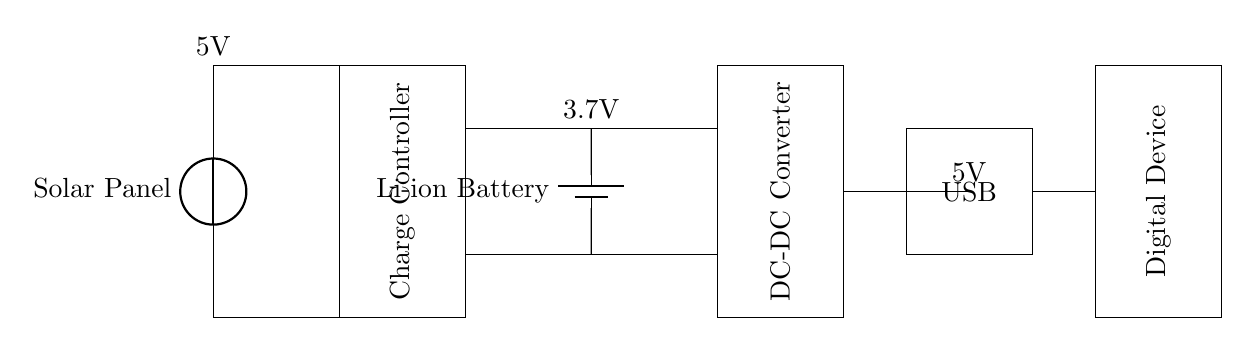What is the voltage of the solar panel? The voltage of the solar panel is represented as 5V in the circuit diagram, indicating the output voltage generated by the panel.
Answer: 5V What type of battery is used in this circuit? The circuit diagram shows a lithium-ion battery, indicated by the label "Li-ion Battery," which is common for portable devices due to its high energy density.
Answer: Li-ion Battery What is the role of the charge controller in this circuit? The charge controller manages the flow of energy from the solar panel to the battery, ensuring the battery is charged safely and preventing overcharging, which is essential for battery health.
Answer: Regulates charging What is the output voltage at the USB port? The output voltage at the USB port is also 5V, matching the output from the solar panel and standard for USB devices, facilitating compatibility with various digital equipment.
Answer: 5V How does the DC-DC converter function in this circuit? The DC-DC converter steps down or regulates the voltage from the battery (3.7V) to a consistent output (5V) suitable for powering the USB-connected digital devices, ensuring adequate power supply regardless of battery charge levels.
Answer: Voltage regulation Which component converts solar energy into electrical energy? The component responsible for converting solar energy into electrical energy is the solar panel. It captures sunlight and generates an electrical current that can be used to charge the battery and power the devices.
Answer: Solar Panel What connects the digital device to the power source? The connection between the digital device and the power source is made through the USB output, which serves as a direct interface for transferring power from the circuit to the device for charging or operation.
Answer: USB Output 